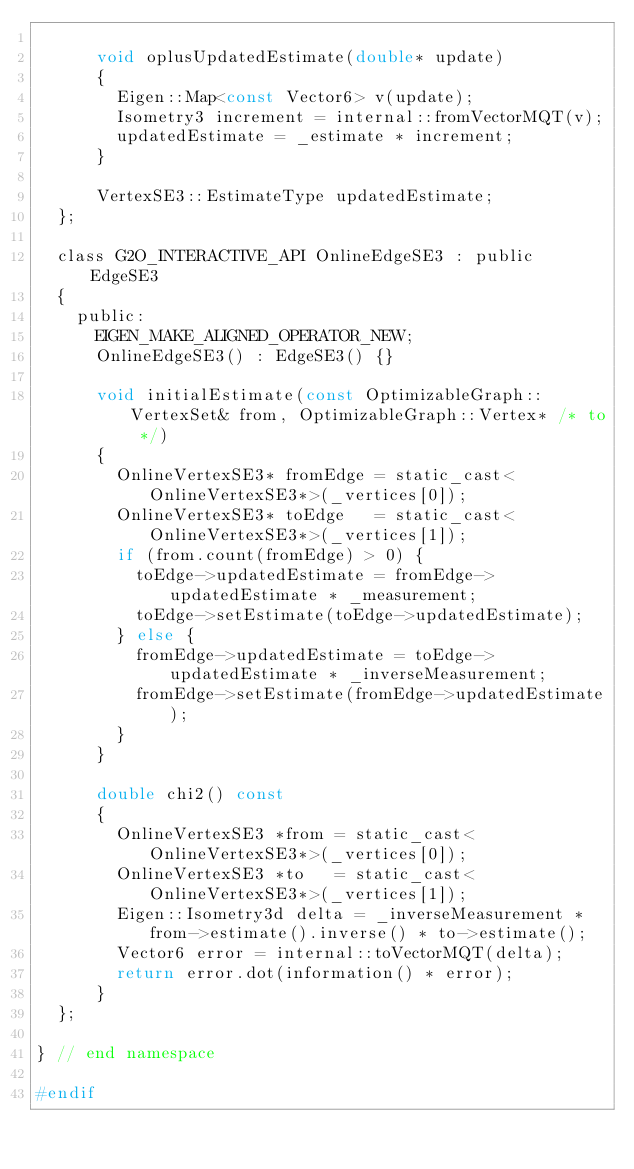<code> <loc_0><loc_0><loc_500><loc_500><_C_>
      void oplusUpdatedEstimate(double* update)
      {
        Eigen::Map<const Vector6> v(update);
        Isometry3 increment = internal::fromVectorMQT(v);
        updatedEstimate = _estimate * increment;
      }

      VertexSE3::EstimateType updatedEstimate;
  };

  class G2O_INTERACTIVE_API OnlineEdgeSE3 : public EdgeSE3
  {
    public:
      EIGEN_MAKE_ALIGNED_OPERATOR_NEW;
      OnlineEdgeSE3() : EdgeSE3() {}

      void initialEstimate(const OptimizableGraph::VertexSet& from, OptimizableGraph::Vertex* /* to */)
      {
        OnlineVertexSE3* fromEdge = static_cast<OnlineVertexSE3*>(_vertices[0]);
        OnlineVertexSE3* toEdge   = static_cast<OnlineVertexSE3*>(_vertices[1]);
        if (from.count(fromEdge) > 0) {
          toEdge->updatedEstimate = fromEdge->updatedEstimate * _measurement;
          toEdge->setEstimate(toEdge->updatedEstimate);
        } else {
          fromEdge->updatedEstimate = toEdge->updatedEstimate * _inverseMeasurement;
          fromEdge->setEstimate(fromEdge->updatedEstimate);
        }
      }

      double chi2() const
      {
        OnlineVertexSE3 *from = static_cast<OnlineVertexSE3*>(_vertices[0]);
        OnlineVertexSE3 *to   = static_cast<OnlineVertexSE3*>(_vertices[1]);
        Eigen::Isometry3d delta = _inverseMeasurement * from->estimate().inverse() * to->estimate();
        Vector6 error = internal::toVectorMQT(delta);
        return error.dot(information() * error);
      }
  };

} // end namespace

#endif
</code> 